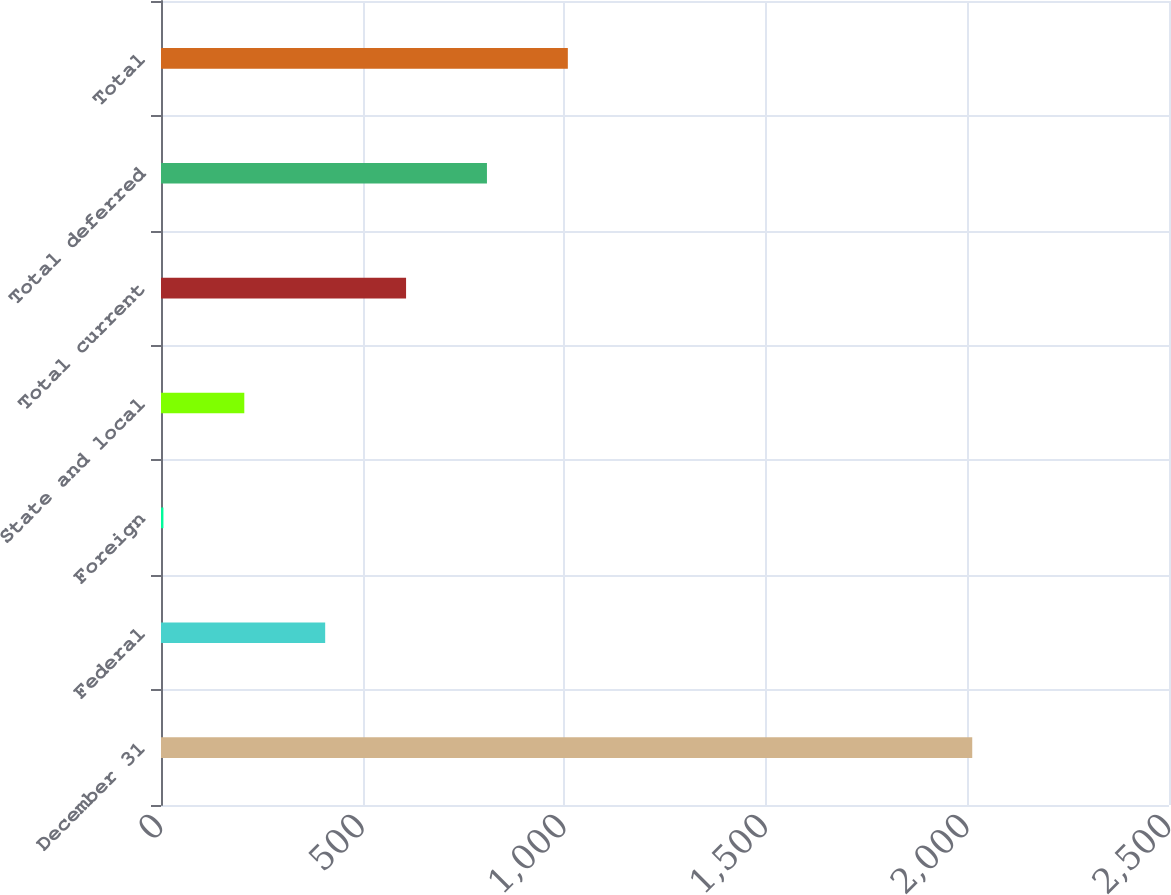<chart> <loc_0><loc_0><loc_500><loc_500><bar_chart><fcel>December 31<fcel>Federal<fcel>Foreign<fcel>State and local<fcel>Total current<fcel>Total deferred<fcel>Total<nl><fcel>2012<fcel>407.2<fcel>6<fcel>206.6<fcel>607.8<fcel>808.4<fcel>1009<nl></chart> 